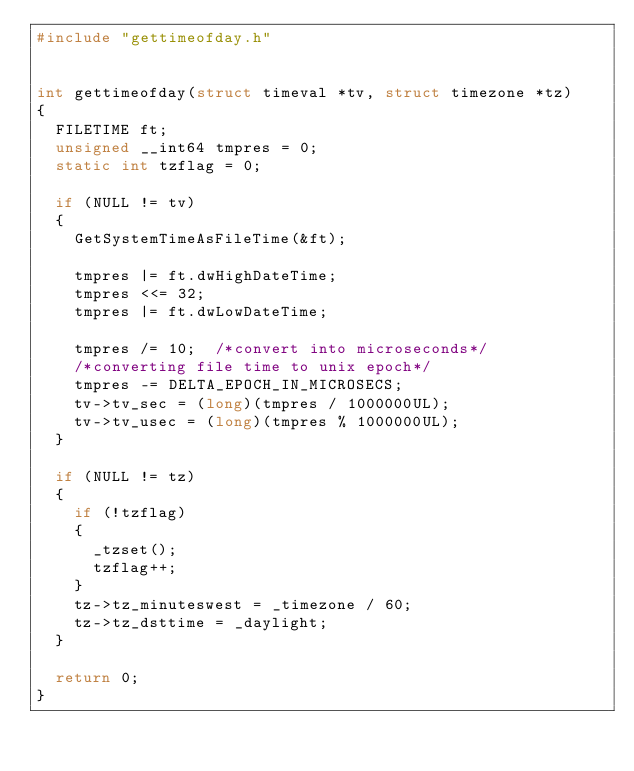Convert code to text. <code><loc_0><loc_0><loc_500><loc_500><_C_>#include "gettimeofday.h"


int gettimeofday(struct timeval *tv, struct timezone *tz)
{
  FILETIME ft;
  unsigned __int64 tmpres = 0;
  static int tzflag = 0;

  if (NULL != tv)
  {
    GetSystemTimeAsFileTime(&ft);

    tmpres |= ft.dwHighDateTime;
    tmpres <<= 32;
    tmpres |= ft.dwLowDateTime;

    tmpres /= 10;  /*convert into microseconds*/
    /*converting file time to unix epoch*/
    tmpres -= DELTA_EPOCH_IN_MICROSECS; 
    tv->tv_sec = (long)(tmpres / 1000000UL);
    tv->tv_usec = (long)(tmpres % 1000000UL);
  }

  if (NULL != tz)
  {
    if (!tzflag)
    {
      _tzset();
      tzflag++;
    }
    tz->tz_minuteswest = _timezone / 60;
    tz->tz_dsttime = _daylight;
  }

  return 0;
}
</code> 